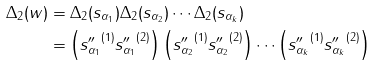<formula> <loc_0><loc_0><loc_500><loc_500>\Delta _ { 2 } ( w ) & = \Delta _ { 2 } ( s _ { \alpha _ { 1 } } ) \Delta _ { 2 } ( s _ { \alpha _ { 2 } } ) \cdots \Delta _ { 2 } ( s _ { \alpha _ { k } } ) \\ & = \left ( { s ^ { \prime \prime } _ { \alpha _ { 1 } } } ^ { ( 1 ) } { s ^ { \prime \prime } _ { \alpha _ { 1 } } } ^ { ( 2 ) } \right ) \left ( { s ^ { \prime \prime } _ { \alpha _ { 2 } } } ^ { ( 1 ) } { s ^ { \prime \prime } _ { \alpha _ { 2 } } } ^ { ( 2 ) } \right ) \cdots \left ( { s ^ { \prime \prime } _ { \alpha _ { k } } } ^ { ( 1 ) } { s ^ { \prime \prime } _ { \alpha _ { k } } } ^ { ( 2 ) } \right )</formula> 